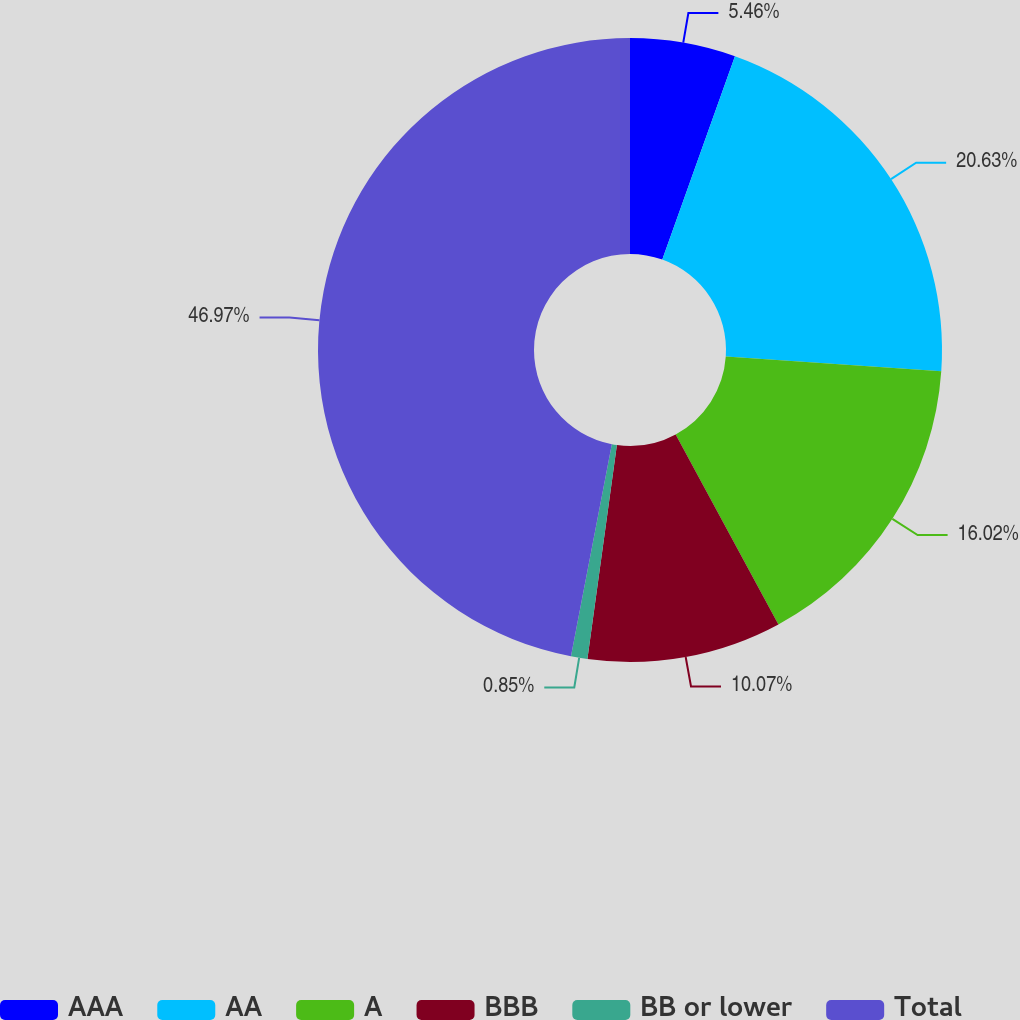Convert chart. <chart><loc_0><loc_0><loc_500><loc_500><pie_chart><fcel>AAA<fcel>AA<fcel>A<fcel>BBB<fcel>BB or lower<fcel>Total<nl><fcel>5.46%<fcel>20.63%<fcel>16.02%<fcel>10.07%<fcel>0.85%<fcel>46.97%<nl></chart> 